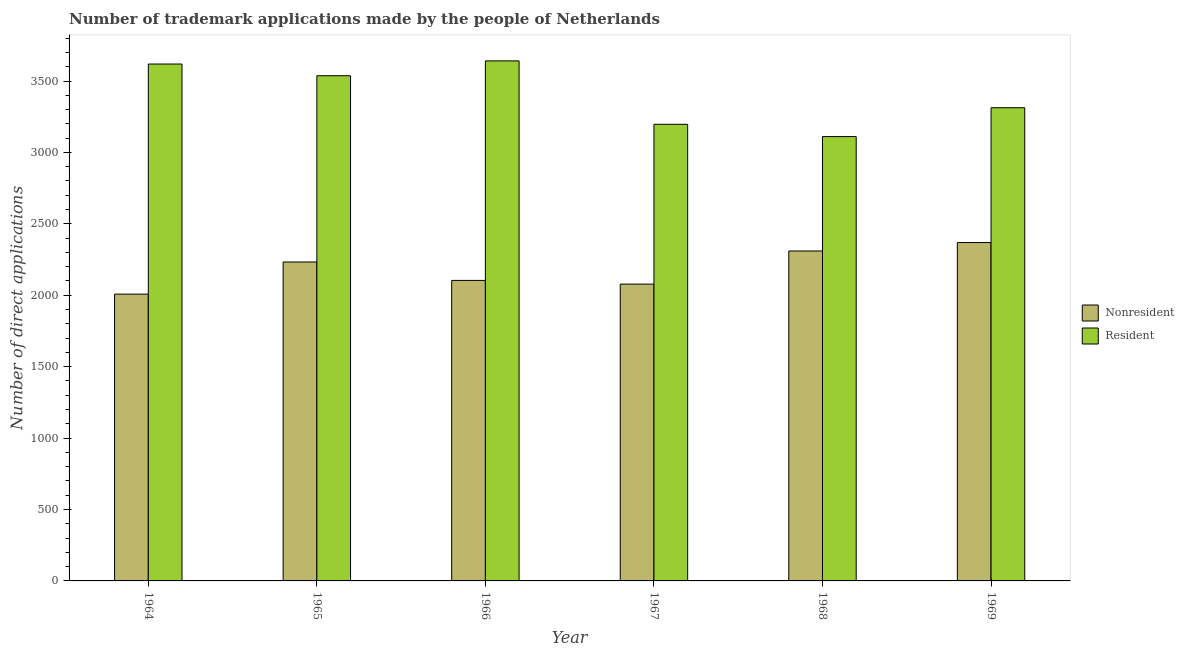How many bars are there on the 1st tick from the left?
Provide a short and direct response. 2. How many bars are there on the 3rd tick from the right?
Your response must be concise. 2. What is the label of the 6th group of bars from the left?
Ensure brevity in your answer.  1969. What is the number of trademark applications made by non residents in 1967?
Provide a short and direct response. 2078. Across all years, what is the maximum number of trademark applications made by residents?
Provide a short and direct response. 3641. Across all years, what is the minimum number of trademark applications made by residents?
Provide a short and direct response. 3111. In which year was the number of trademark applications made by non residents maximum?
Provide a short and direct response. 1969. In which year was the number of trademark applications made by residents minimum?
Offer a very short reply. 1968. What is the total number of trademark applications made by non residents in the graph?
Your answer should be very brief. 1.31e+04. What is the difference between the number of trademark applications made by non residents in 1965 and that in 1968?
Your answer should be compact. -77. What is the difference between the number of trademark applications made by residents in 1969 and the number of trademark applications made by non residents in 1966?
Ensure brevity in your answer.  -328. What is the average number of trademark applications made by non residents per year?
Your answer should be compact. 2183.67. In the year 1968, what is the difference between the number of trademark applications made by residents and number of trademark applications made by non residents?
Provide a short and direct response. 0. In how many years, is the number of trademark applications made by residents greater than 2200?
Ensure brevity in your answer.  6. What is the ratio of the number of trademark applications made by residents in 1965 to that in 1969?
Ensure brevity in your answer.  1.07. Is the number of trademark applications made by non residents in 1967 less than that in 1969?
Give a very brief answer. Yes. Is the difference between the number of trademark applications made by residents in 1965 and 1969 greater than the difference between the number of trademark applications made by non residents in 1965 and 1969?
Your answer should be compact. No. What is the difference between the highest and the second highest number of trademark applications made by non residents?
Your response must be concise. 59. What is the difference between the highest and the lowest number of trademark applications made by residents?
Keep it short and to the point. 530. In how many years, is the number of trademark applications made by residents greater than the average number of trademark applications made by residents taken over all years?
Your response must be concise. 3. Is the sum of the number of trademark applications made by non residents in 1964 and 1966 greater than the maximum number of trademark applications made by residents across all years?
Offer a terse response. Yes. What does the 2nd bar from the left in 1964 represents?
Keep it short and to the point. Resident. What does the 2nd bar from the right in 1968 represents?
Make the answer very short. Nonresident. Are all the bars in the graph horizontal?
Make the answer very short. No. How many years are there in the graph?
Offer a terse response. 6. Does the graph contain any zero values?
Ensure brevity in your answer.  No. Does the graph contain grids?
Your response must be concise. No. How many legend labels are there?
Your answer should be compact. 2. How are the legend labels stacked?
Your response must be concise. Vertical. What is the title of the graph?
Your response must be concise. Number of trademark applications made by the people of Netherlands. What is the label or title of the X-axis?
Ensure brevity in your answer.  Year. What is the label or title of the Y-axis?
Give a very brief answer. Number of direct applications. What is the Number of direct applications of Nonresident in 1964?
Your response must be concise. 2008. What is the Number of direct applications in Resident in 1964?
Offer a very short reply. 3619. What is the Number of direct applications in Nonresident in 1965?
Your response must be concise. 2233. What is the Number of direct applications of Resident in 1965?
Your answer should be very brief. 3537. What is the Number of direct applications in Nonresident in 1966?
Ensure brevity in your answer.  2104. What is the Number of direct applications in Resident in 1966?
Ensure brevity in your answer.  3641. What is the Number of direct applications in Nonresident in 1967?
Your answer should be compact. 2078. What is the Number of direct applications of Resident in 1967?
Your response must be concise. 3197. What is the Number of direct applications in Nonresident in 1968?
Your answer should be compact. 2310. What is the Number of direct applications of Resident in 1968?
Your answer should be very brief. 3111. What is the Number of direct applications in Nonresident in 1969?
Provide a short and direct response. 2369. What is the Number of direct applications of Resident in 1969?
Make the answer very short. 3313. Across all years, what is the maximum Number of direct applications in Nonresident?
Ensure brevity in your answer.  2369. Across all years, what is the maximum Number of direct applications of Resident?
Provide a succinct answer. 3641. Across all years, what is the minimum Number of direct applications of Nonresident?
Your response must be concise. 2008. Across all years, what is the minimum Number of direct applications in Resident?
Make the answer very short. 3111. What is the total Number of direct applications in Nonresident in the graph?
Your answer should be very brief. 1.31e+04. What is the total Number of direct applications of Resident in the graph?
Give a very brief answer. 2.04e+04. What is the difference between the Number of direct applications in Nonresident in 1964 and that in 1965?
Your answer should be compact. -225. What is the difference between the Number of direct applications in Resident in 1964 and that in 1965?
Provide a short and direct response. 82. What is the difference between the Number of direct applications of Nonresident in 1964 and that in 1966?
Provide a short and direct response. -96. What is the difference between the Number of direct applications in Nonresident in 1964 and that in 1967?
Give a very brief answer. -70. What is the difference between the Number of direct applications in Resident in 1964 and that in 1967?
Provide a succinct answer. 422. What is the difference between the Number of direct applications of Nonresident in 1964 and that in 1968?
Provide a succinct answer. -302. What is the difference between the Number of direct applications of Resident in 1964 and that in 1968?
Your response must be concise. 508. What is the difference between the Number of direct applications of Nonresident in 1964 and that in 1969?
Your answer should be very brief. -361. What is the difference between the Number of direct applications of Resident in 1964 and that in 1969?
Your answer should be compact. 306. What is the difference between the Number of direct applications of Nonresident in 1965 and that in 1966?
Your answer should be compact. 129. What is the difference between the Number of direct applications in Resident in 1965 and that in 1966?
Give a very brief answer. -104. What is the difference between the Number of direct applications of Nonresident in 1965 and that in 1967?
Your response must be concise. 155. What is the difference between the Number of direct applications of Resident in 1965 and that in 1967?
Your answer should be very brief. 340. What is the difference between the Number of direct applications in Nonresident in 1965 and that in 1968?
Your response must be concise. -77. What is the difference between the Number of direct applications in Resident in 1965 and that in 1968?
Offer a very short reply. 426. What is the difference between the Number of direct applications in Nonresident in 1965 and that in 1969?
Give a very brief answer. -136. What is the difference between the Number of direct applications in Resident in 1965 and that in 1969?
Ensure brevity in your answer.  224. What is the difference between the Number of direct applications of Nonresident in 1966 and that in 1967?
Provide a succinct answer. 26. What is the difference between the Number of direct applications of Resident in 1966 and that in 1967?
Offer a very short reply. 444. What is the difference between the Number of direct applications of Nonresident in 1966 and that in 1968?
Keep it short and to the point. -206. What is the difference between the Number of direct applications in Resident in 1966 and that in 1968?
Make the answer very short. 530. What is the difference between the Number of direct applications in Nonresident in 1966 and that in 1969?
Your response must be concise. -265. What is the difference between the Number of direct applications of Resident in 1966 and that in 1969?
Your response must be concise. 328. What is the difference between the Number of direct applications of Nonresident in 1967 and that in 1968?
Your answer should be very brief. -232. What is the difference between the Number of direct applications of Resident in 1967 and that in 1968?
Keep it short and to the point. 86. What is the difference between the Number of direct applications in Nonresident in 1967 and that in 1969?
Your answer should be very brief. -291. What is the difference between the Number of direct applications in Resident in 1967 and that in 1969?
Your answer should be compact. -116. What is the difference between the Number of direct applications in Nonresident in 1968 and that in 1969?
Provide a succinct answer. -59. What is the difference between the Number of direct applications in Resident in 1968 and that in 1969?
Make the answer very short. -202. What is the difference between the Number of direct applications of Nonresident in 1964 and the Number of direct applications of Resident in 1965?
Offer a very short reply. -1529. What is the difference between the Number of direct applications of Nonresident in 1964 and the Number of direct applications of Resident in 1966?
Give a very brief answer. -1633. What is the difference between the Number of direct applications in Nonresident in 1964 and the Number of direct applications in Resident in 1967?
Keep it short and to the point. -1189. What is the difference between the Number of direct applications of Nonresident in 1964 and the Number of direct applications of Resident in 1968?
Provide a short and direct response. -1103. What is the difference between the Number of direct applications in Nonresident in 1964 and the Number of direct applications in Resident in 1969?
Keep it short and to the point. -1305. What is the difference between the Number of direct applications in Nonresident in 1965 and the Number of direct applications in Resident in 1966?
Provide a succinct answer. -1408. What is the difference between the Number of direct applications of Nonresident in 1965 and the Number of direct applications of Resident in 1967?
Provide a succinct answer. -964. What is the difference between the Number of direct applications of Nonresident in 1965 and the Number of direct applications of Resident in 1968?
Keep it short and to the point. -878. What is the difference between the Number of direct applications of Nonresident in 1965 and the Number of direct applications of Resident in 1969?
Your response must be concise. -1080. What is the difference between the Number of direct applications in Nonresident in 1966 and the Number of direct applications in Resident in 1967?
Keep it short and to the point. -1093. What is the difference between the Number of direct applications of Nonresident in 1966 and the Number of direct applications of Resident in 1968?
Your answer should be very brief. -1007. What is the difference between the Number of direct applications in Nonresident in 1966 and the Number of direct applications in Resident in 1969?
Offer a very short reply. -1209. What is the difference between the Number of direct applications in Nonresident in 1967 and the Number of direct applications in Resident in 1968?
Provide a succinct answer. -1033. What is the difference between the Number of direct applications of Nonresident in 1967 and the Number of direct applications of Resident in 1969?
Provide a short and direct response. -1235. What is the difference between the Number of direct applications in Nonresident in 1968 and the Number of direct applications in Resident in 1969?
Offer a terse response. -1003. What is the average Number of direct applications of Nonresident per year?
Your answer should be very brief. 2183.67. What is the average Number of direct applications in Resident per year?
Ensure brevity in your answer.  3403. In the year 1964, what is the difference between the Number of direct applications of Nonresident and Number of direct applications of Resident?
Your answer should be compact. -1611. In the year 1965, what is the difference between the Number of direct applications in Nonresident and Number of direct applications in Resident?
Your answer should be compact. -1304. In the year 1966, what is the difference between the Number of direct applications of Nonresident and Number of direct applications of Resident?
Provide a short and direct response. -1537. In the year 1967, what is the difference between the Number of direct applications in Nonresident and Number of direct applications in Resident?
Offer a very short reply. -1119. In the year 1968, what is the difference between the Number of direct applications in Nonresident and Number of direct applications in Resident?
Your answer should be compact. -801. In the year 1969, what is the difference between the Number of direct applications of Nonresident and Number of direct applications of Resident?
Offer a terse response. -944. What is the ratio of the Number of direct applications in Nonresident in 1964 to that in 1965?
Provide a short and direct response. 0.9. What is the ratio of the Number of direct applications of Resident in 1964 to that in 1965?
Give a very brief answer. 1.02. What is the ratio of the Number of direct applications in Nonresident in 1964 to that in 1966?
Provide a short and direct response. 0.95. What is the ratio of the Number of direct applications in Resident in 1964 to that in 1966?
Give a very brief answer. 0.99. What is the ratio of the Number of direct applications in Nonresident in 1964 to that in 1967?
Make the answer very short. 0.97. What is the ratio of the Number of direct applications of Resident in 1964 to that in 1967?
Your answer should be compact. 1.13. What is the ratio of the Number of direct applications of Nonresident in 1964 to that in 1968?
Give a very brief answer. 0.87. What is the ratio of the Number of direct applications of Resident in 1964 to that in 1968?
Your response must be concise. 1.16. What is the ratio of the Number of direct applications of Nonresident in 1964 to that in 1969?
Offer a terse response. 0.85. What is the ratio of the Number of direct applications of Resident in 1964 to that in 1969?
Ensure brevity in your answer.  1.09. What is the ratio of the Number of direct applications in Nonresident in 1965 to that in 1966?
Your answer should be very brief. 1.06. What is the ratio of the Number of direct applications in Resident in 1965 to that in 1966?
Keep it short and to the point. 0.97. What is the ratio of the Number of direct applications in Nonresident in 1965 to that in 1967?
Your answer should be compact. 1.07. What is the ratio of the Number of direct applications in Resident in 1965 to that in 1967?
Ensure brevity in your answer.  1.11. What is the ratio of the Number of direct applications in Nonresident in 1965 to that in 1968?
Ensure brevity in your answer.  0.97. What is the ratio of the Number of direct applications in Resident in 1965 to that in 1968?
Ensure brevity in your answer.  1.14. What is the ratio of the Number of direct applications of Nonresident in 1965 to that in 1969?
Your response must be concise. 0.94. What is the ratio of the Number of direct applications of Resident in 1965 to that in 1969?
Provide a short and direct response. 1.07. What is the ratio of the Number of direct applications of Nonresident in 1966 to that in 1967?
Offer a terse response. 1.01. What is the ratio of the Number of direct applications of Resident in 1966 to that in 1967?
Give a very brief answer. 1.14. What is the ratio of the Number of direct applications in Nonresident in 1966 to that in 1968?
Make the answer very short. 0.91. What is the ratio of the Number of direct applications of Resident in 1966 to that in 1968?
Provide a succinct answer. 1.17. What is the ratio of the Number of direct applications of Nonresident in 1966 to that in 1969?
Provide a short and direct response. 0.89. What is the ratio of the Number of direct applications of Resident in 1966 to that in 1969?
Provide a short and direct response. 1.1. What is the ratio of the Number of direct applications in Nonresident in 1967 to that in 1968?
Offer a terse response. 0.9. What is the ratio of the Number of direct applications of Resident in 1967 to that in 1968?
Give a very brief answer. 1.03. What is the ratio of the Number of direct applications in Nonresident in 1967 to that in 1969?
Your answer should be compact. 0.88. What is the ratio of the Number of direct applications in Nonresident in 1968 to that in 1969?
Offer a terse response. 0.98. What is the ratio of the Number of direct applications in Resident in 1968 to that in 1969?
Keep it short and to the point. 0.94. What is the difference between the highest and the second highest Number of direct applications in Nonresident?
Offer a very short reply. 59. What is the difference between the highest and the lowest Number of direct applications in Nonresident?
Keep it short and to the point. 361. What is the difference between the highest and the lowest Number of direct applications in Resident?
Your answer should be compact. 530. 